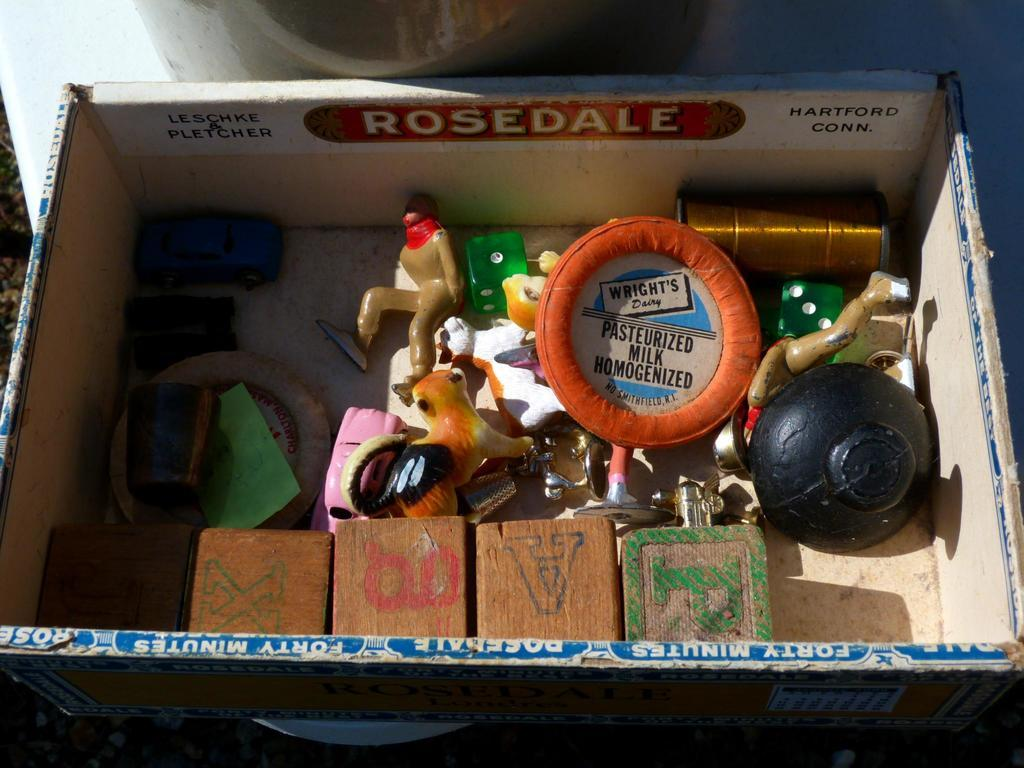What objects are in the image? There are toys in the image. Where are the toys located? The toys are present in a box. Can you describe the position of the box? The box is on the ground. What type of flight can be seen taking off in the image? There is no flight present in the image; it only features toys in a box on the ground. 